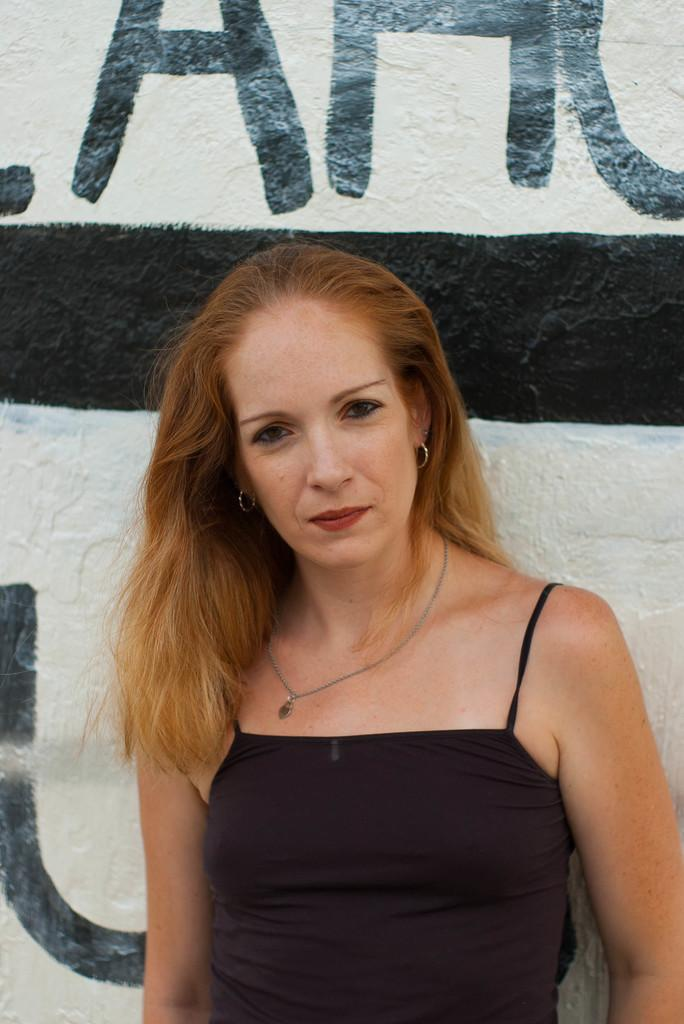Who is the main subject in the image? There is a woman in the center of the image. What can be seen in the background of the image? There is text on the wall in the background of the image. What type of vein is visible on the woman's arm in the image? There is no visible vein on the woman's arm in the image. How does the woman stretch in the image? The woman is not stretching in the image; she is standing in the center. 